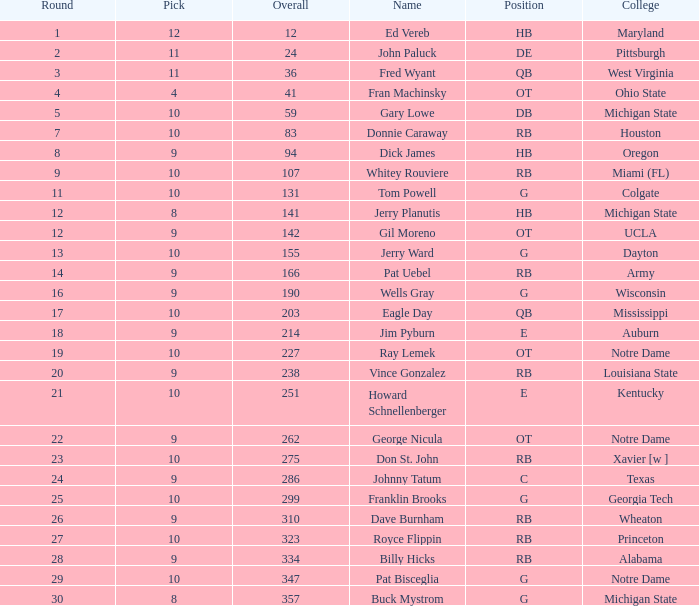Write the full table. {'header': ['Round', 'Pick', 'Overall', 'Name', 'Position', 'College'], 'rows': [['1', '12', '12', 'Ed Vereb', 'HB', 'Maryland'], ['2', '11', '24', 'John Paluck', 'DE', 'Pittsburgh'], ['3', '11', '36', 'Fred Wyant', 'QB', 'West Virginia'], ['4', '4', '41', 'Fran Machinsky', 'OT', 'Ohio State'], ['5', '10', '59', 'Gary Lowe', 'DB', 'Michigan State'], ['7', '10', '83', 'Donnie Caraway', 'RB', 'Houston'], ['8', '9', '94', 'Dick James', 'HB', 'Oregon'], ['9', '10', '107', 'Whitey Rouviere', 'RB', 'Miami (FL)'], ['11', '10', '131', 'Tom Powell', 'G', 'Colgate'], ['12', '8', '141', 'Jerry Planutis', 'HB', 'Michigan State'], ['12', '9', '142', 'Gil Moreno', 'OT', 'UCLA'], ['13', '10', '155', 'Jerry Ward', 'G', 'Dayton'], ['14', '9', '166', 'Pat Uebel', 'RB', 'Army'], ['16', '9', '190', 'Wells Gray', 'G', 'Wisconsin'], ['17', '10', '203', 'Eagle Day', 'QB', 'Mississippi'], ['18', '9', '214', 'Jim Pyburn', 'E', 'Auburn'], ['19', '10', '227', 'Ray Lemek', 'OT', 'Notre Dame'], ['20', '9', '238', 'Vince Gonzalez', 'RB', 'Louisiana State'], ['21', '10', '251', 'Howard Schnellenberger', 'E', 'Kentucky'], ['22', '9', '262', 'George Nicula', 'OT', 'Notre Dame'], ['23', '10', '275', 'Don St. John', 'RB', 'Xavier [w ]'], ['24', '9', '286', 'Johnny Tatum', 'C', 'Texas'], ['25', '10', '299', 'Franklin Brooks', 'G', 'Georgia Tech'], ['26', '9', '310', 'Dave Burnham', 'RB', 'Wheaton'], ['27', '10', '323', 'Royce Flippin', 'RB', 'Princeton'], ['28', '9', '334', 'Billy Hicks', 'RB', 'Alabama'], ['29', '10', '347', 'Pat Bisceglia', 'G', 'Notre Dame'], ['30', '8', '357', 'Buck Mystrom', 'G', 'Michigan State']]} What is the average number of rounds for billy hicks who had an overall pick number bigger than 310? 28.0. 